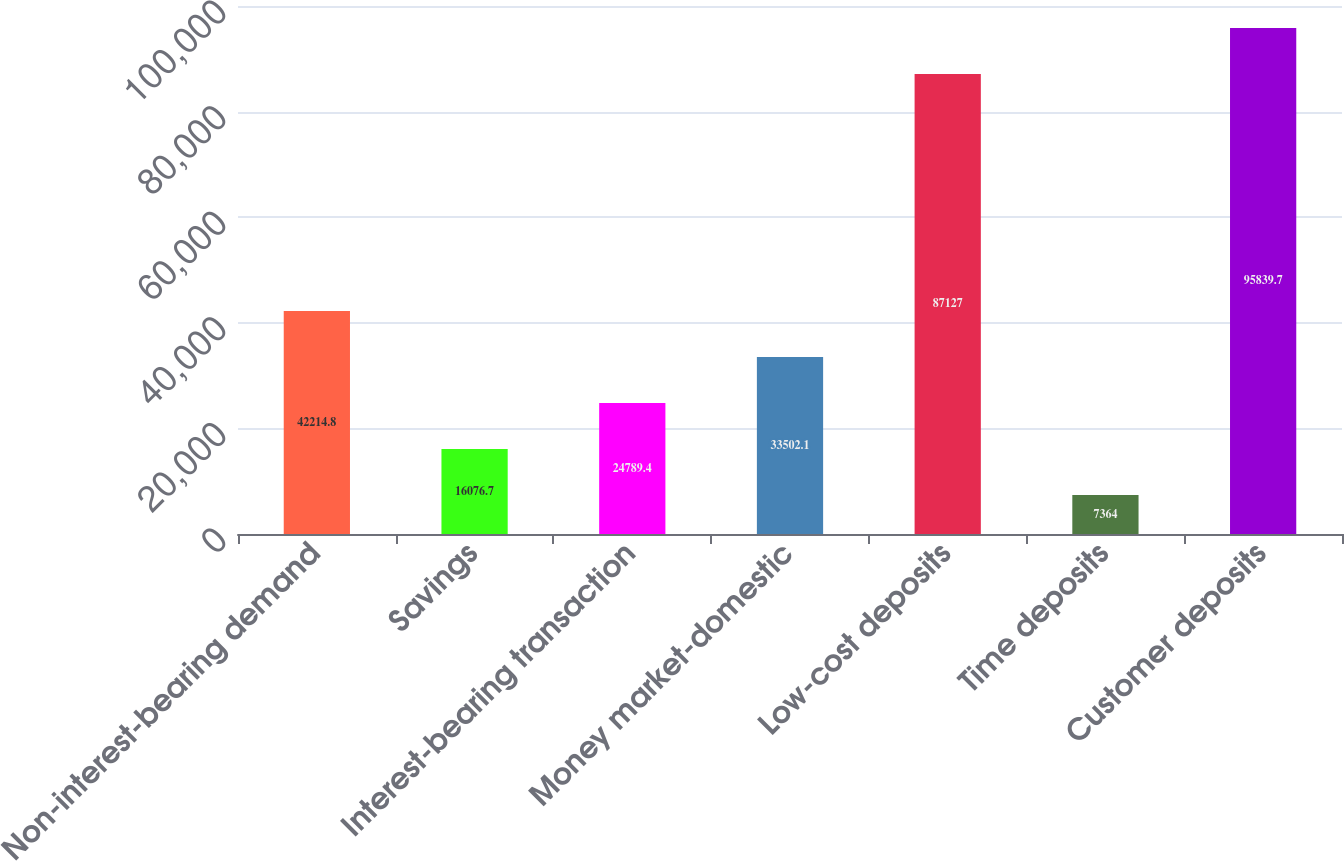Convert chart. <chart><loc_0><loc_0><loc_500><loc_500><bar_chart><fcel>Non-interest-bearing demand<fcel>Savings<fcel>Interest-bearing transaction<fcel>Money market-domestic<fcel>Low-cost deposits<fcel>Time deposits<fcel>Customer deposits<nl><fcel>42214.8<fcel>16076.7<fcel>24789.4<fcel>33502.1<fcel>87127<fcel>7364<fcel>95839.7<nl></chart> 